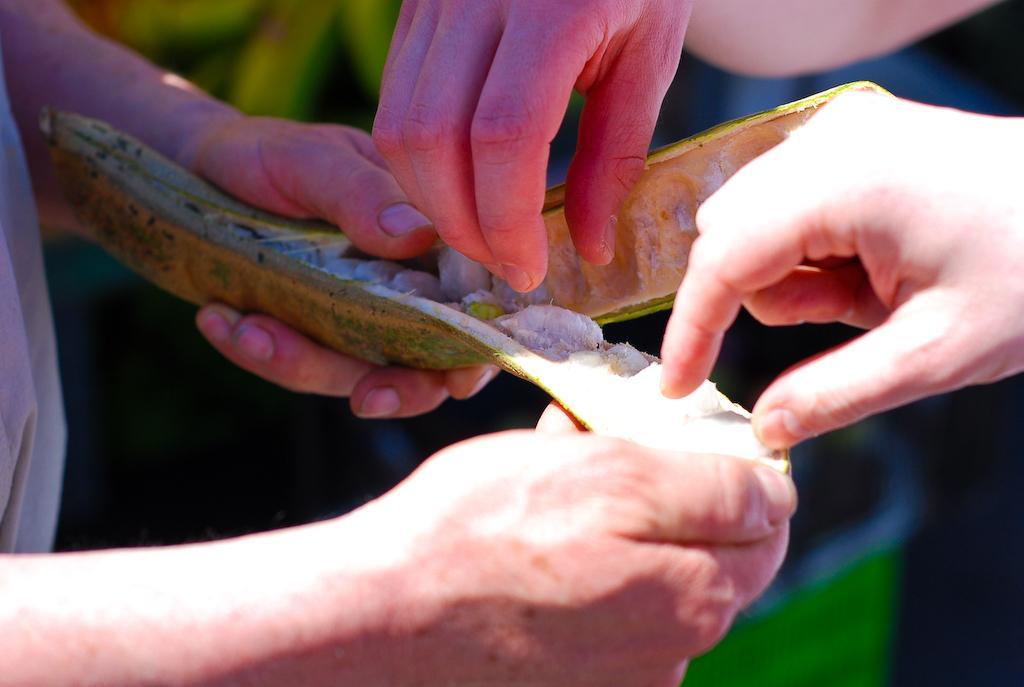How would you summarize this image in a sentence or two? In this picture I can see a person's hands in front and holding a green color thing and I see 2 other hands of persons. I see that it is blurred in the background. 